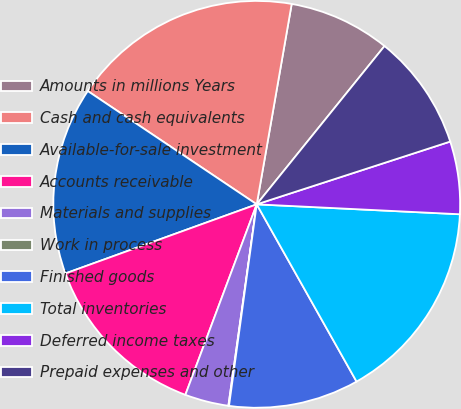<chart> <loc_0><loc_0><loc_500><loc_500><pie_chart><fcel>Amounts in millions Years<fcel>Cash and cash equivalents<fcel>Available-for-sale investment<fcel>Accounts receivable<fcel>Materials and supplies<fcel>Work in process<fcel>Finished goods<fcel>Total inventories<fcel>Deferred income taxes<fcel>Prepaid expenses and other<nl><fcel>8.06%<fcel>18.35%<fcel>14.92%<fcel>13.78%<fcel>3.48%<fcel>0.05%<fcel>10.34%<fcel>16.06%<fcel>5.77%<fcel>9.2%<nl></chart> 